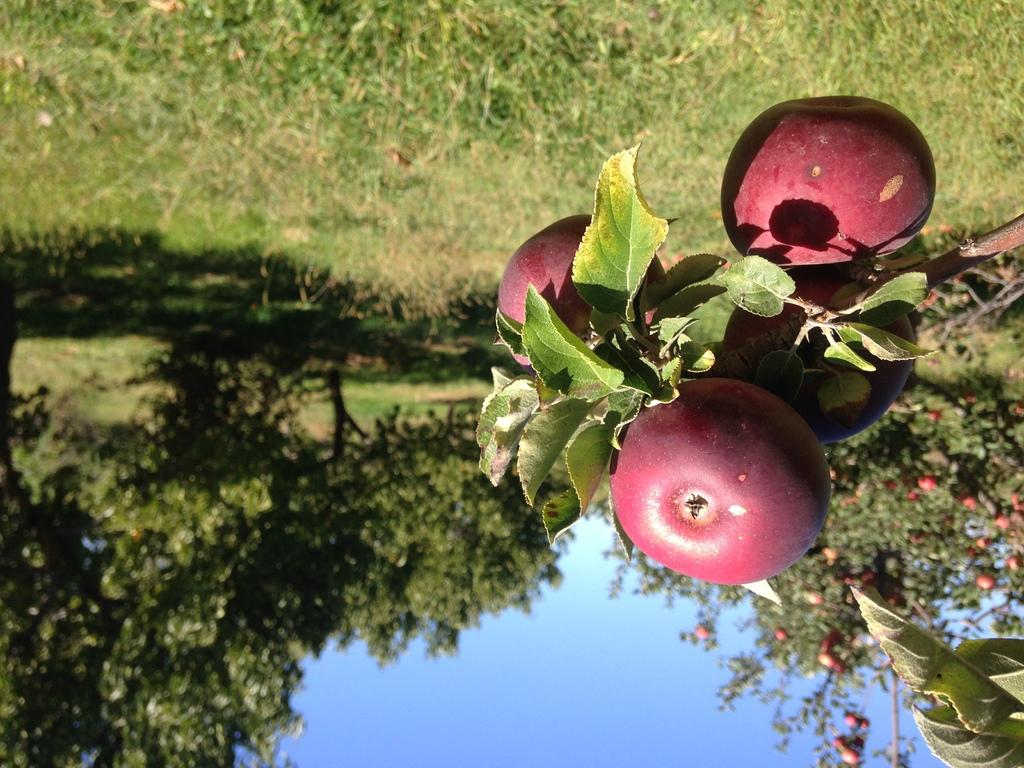What type of vegetation is present in the image? There is grass in the image. What other natural elements can be seen in the image? There are trees in the image. What type of fruit is visible in the image? There are apples in the image. What is visible in the background of the image? The sky is visible in the background of the image. Where can the scissors be found in the image? There are no scissors present in the image. What type of knowledge can be gained from the library in the image? There is no library present in the image, so it is not possible to gain knowledge from it. 